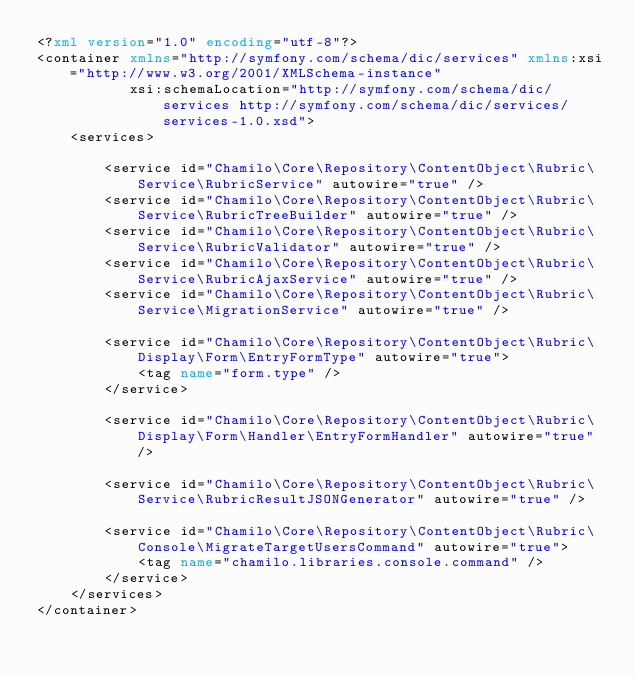Convert code to text. <code><loc_0><loc_0><loc_500><loc_500><_XML_><?xml version="1.0" encoding="utf-8"?>
<container xmlns="http://symfony.com/schema/dic/services" xmlns:xsi="http://www.w3.org/2001/XMLSchema-instance"
           xsi:schemaLocation="http://symfony.com/schema/dic/services http://symfony.com/schema/dic/services/services-1.0.xsd">
    <services>

        <service id="Chamilo\Core\Repository\ContentObject\Rubric\Service\RubricService" autowire="true" />
        <service id="Chamilo\Core\Repository\ContentObject\Rubric\Service\RubricTreeBuilder" autowire="true" />
        <service id="Chamilo\Core\Repository\ContentObject\Rubric\Service\RubricValidator" autowire="true" />
        <service id="Chamilo\Core\Repository\ContentObject\Rubric\Service\RubricAjaxService" autowire="true" />
        <service id="Chamilo\Core\Repository\ContentObject\Rubric\Service\MigrationService" autowire="true" />

        <service id="Chamilo\Core\Repository\ContentObject\Rubric\Display\Form\EntryFormType" autowire="true">
            <tag name="form.type" />
        </service>

        <service id="Chamilo\Core\Repository\ContentObject\Rubric\Display\Form\Handler\EntryFormHandler" autowire="true" />

        <service id="Chamilo\Core\Repository\ContentObject\Rubric\Service\RubricResultJSONGenerator" autowire="true" />

        <service id="Chamilo\Core\Repository\ContentObject\Rubric\Console\MigrateTargetUsersCommand" autowire="true">
            <tag name="chamilo.libraries.console.command" />
        </service>
    </services>
</container>
</code> 